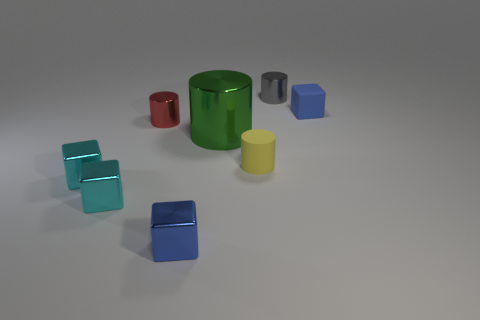Are the small blue object on the left side of the gray metal cylinder and the blue block that is behind the yellow matte cylinder made of the same material?
Provide a succinct answer. No. What number of other things are the same material as the green cylinder?
Give a very brief answer. 5. Is the material of the big green cylinder the same as the cube on the right side of the tiny yellow cylinder?
Offer a terse response. No. Is there any other thing that is the same size as the green metal thing?
Offer a very short reply. No. What is the size of the green cylinder that is the same material as the gray object?
Keep it short and to the point. Large. How many objects are either blue cubes that are behind the big green metal thing or blue objects that are behind the large green cylinder?
Provide a short and direct response. 1. Do the cube right of the gray object and the red cylinder have the same size?
Your answer should be compact. Yes. There is a matte object that is in front of the big green object; what color is it?
Ensure brevity in your answer.  Yellow. The big thing that is the same shape as the small yellow rubber thing is what color?
Make the answer very short. Green. There is a tiny blue object right of the tiny blue object in front of the big green cylinder; how many green objects are behind it?
Your answer should be very brief. 0. 